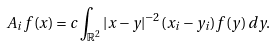Convert formula to latex. <formula><loc_0><loc_0><loc_500><loc_500>A _ { i } f ( x ) = c \int _ { \mathbb { R } ^ { 2 } } | x - y | ^ { - 2 } ( x _ { i } - y _ { i } ) f ( y ) \, d y .</formula> 